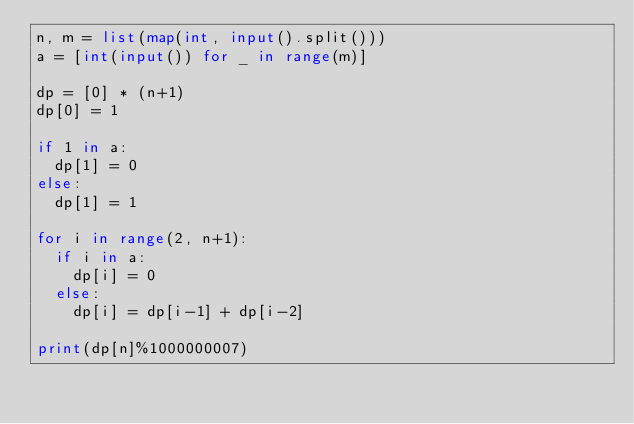<code> <loc_0><loc_0><loc_500><loc_500><_Python_>n, m = list(map(int, input().split()))
a = [int(input()) for _ in range(m)]

dp = [0] * (n+1)
dp[0] = 1

if 1 in a:
  dp[1] = 0
else:
  dp[1] = 1
  
for i in range(2, n+1):
  if i in a:
    dp[i] = 0
  else:
    dp[i] = dp[i-1] + dp[i-2]
  
print(dp[n]%1000000007)</code> 